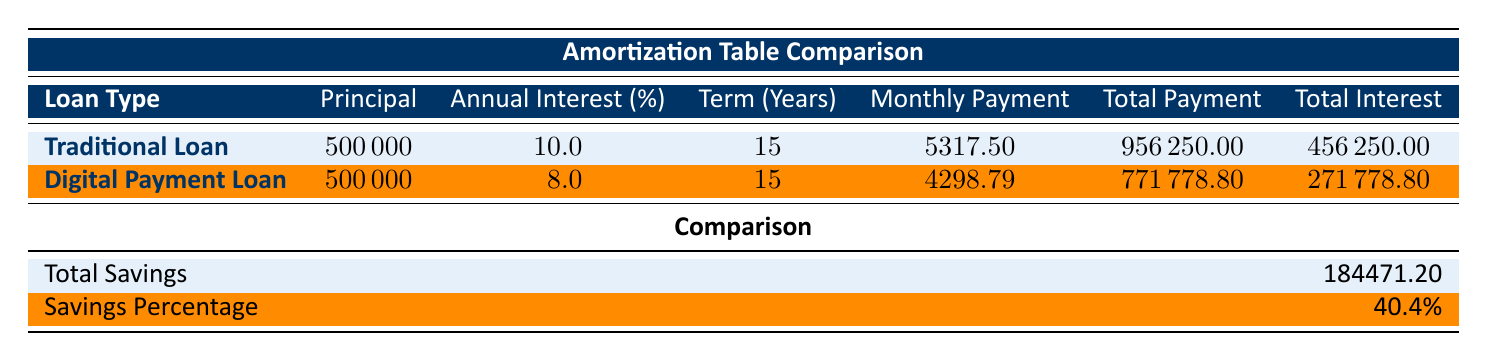What is the principal amount for both loan types? The principal amount for both loan types is explicitly stated in the table under the "Principal" column. For both the Traditional Loan and the Digital Payment Loan, the principal is 500,000.
Answer: 500000 What is the annual interest rate for the Digital Payment Loan? To find the annual interest rate for the Digital Payment Loan, we can look at the "Annual Interest (%)" column directly associated with that loan type. It shows the rate as 8.0%.
Answer: 8.0 How much total interest is paid for the Traditional Loan? The total interest paid for the Traditional Loan is listed directly in the table under the "Total Interest" column, which shows 456,250.
Answer: 456250 What is the savings percentage when choosing the Digital Payment Loan over the Traditional Loan? The savings percentage is mentioned in the "Comparison" section of the table as 40.4%. This value shows the percentage of savings realized by choosing a Digital Payment Loan instead of a Traditional Loan.
Answer: 40.4% What is the total payment amount for the Digital Payment Loan? The total payment amount for the Digital Payment Loan is provided in the "Total Payment" column and is recorded as 771,778.80.
Answer: 771778.80 If a borrower chooses the Digital Payment Loan, how much do they save in total compared to the Traditional Loan? To calculate the savings, we refer to the "Total Savings" value in the comparison section of the table, which states the total savings as 184,471.20.
Answer: 184471.20 Is the monthly payment for the Traditional Loan higher than for the Digital Payment Loan? By comparing the "Monthly Payment" values for both loan types, we find that the Traditional Loan has a monthly payment of 5,317.50, while the Digital Payment Loan has a monthly payment of 4,298.79. Thus, the statement is true.
Answer: Yes Which loan accrues less total payment over its term, Traditional Loan or Digital Payment Loan? By comparing the "Total Payment" values, we find that the Traditional Loan totals 956,250, while the Digital Payment Loan totals 771,778.80. Since 771,778.80 is less than 956,250, the Digital Payment Loan accrues less total payment.
Answer: Digital Payment Loan Calculating the difference in total payments, how much more does the Traditional Loan cost compared to the Digital Payment Loan? To calculate the difference, subtract the total payment of the Digital Payment Loan from the total payment of the Traditional Loan: 956,250 - 771,778.80 = 184,471.20. This value represents how much more the Traditional Loan costs.
Answer: 184471.20 What would the total interest paid be if the annual interest rate for the Traditional Loan were reduced to 9% instead of 10%? This question involves complex reasoning because we would need to recalculate the amortization schedule for a hypothetical scenario using financial formulas. The table does not provide sufficient data to make this calculation directly. Therefore, we cannot provide an answer based on the existing data.
Answer: Indeterminate 